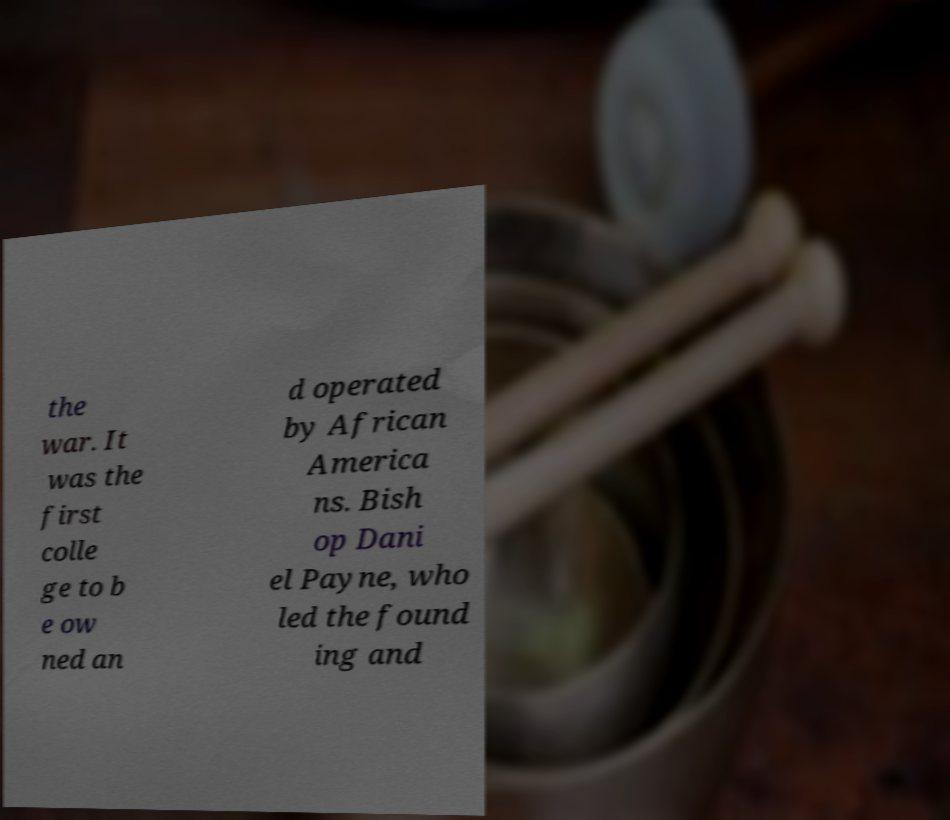Could you extract and type out the text from this image? the war. It was the first colle ge to b e ow ned an d operated by African America ns. Bish op Dani el Payne, who led the found ing and 